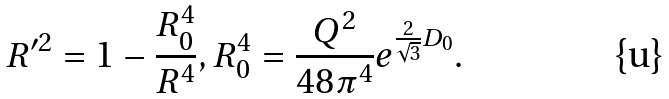<formula> <loc_0><loc_0><loc_500><loc_500>R ^ { \prime 2 } = 1 - \frac { R _ { 0 } ^ { 4 } } { R ^ { 4 } } , R _ { 0 } ^ { 4 } = \frac { Q ^ { 2 } } { 4 8 \pi ^ { 4 } } e ^ { \frac { 2 } { \sqrt { 3 } } D _ { 0 } } .</formula> 